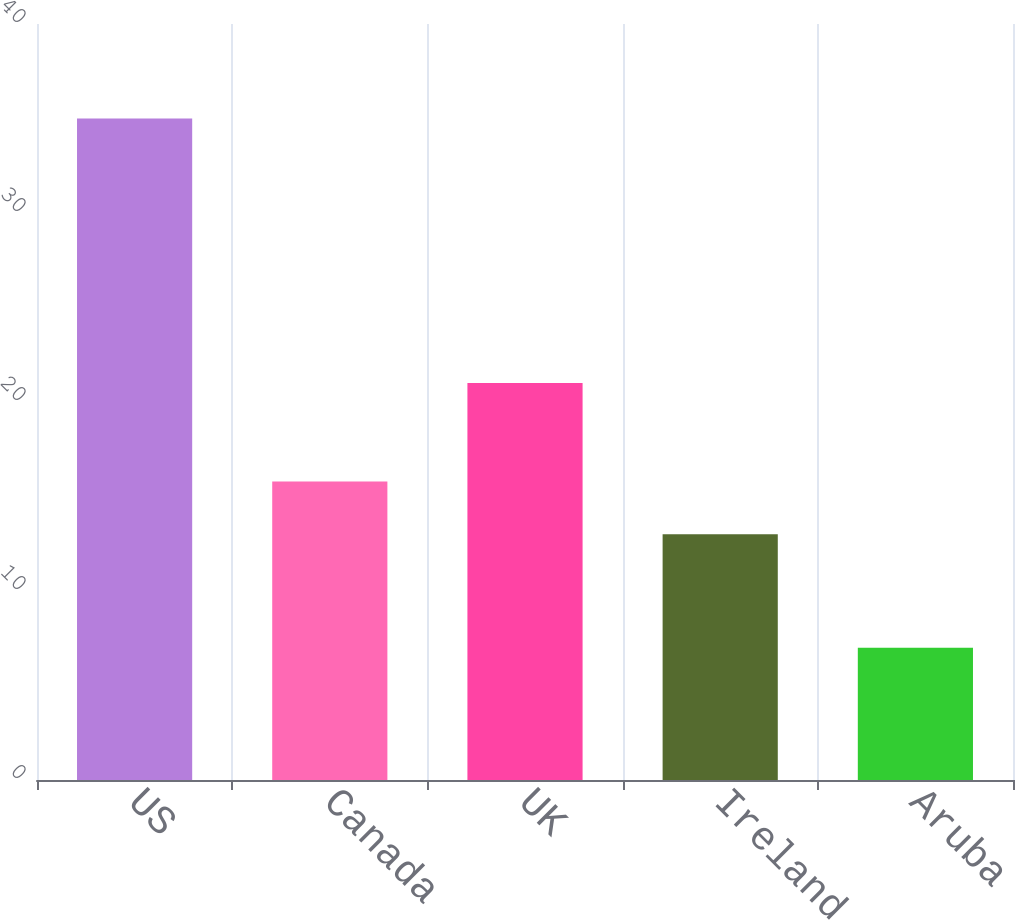<chart> <loc_0><loc_0><loc_500><loc_500><bar_chart><fcel>US<fcel>Canada<fcel>UK<fcel>Ireland<fcel>Aruba<nl><fcel>35<fcel>15.8<fcel>21<fcel>13<fcel>7<nl></chart> 